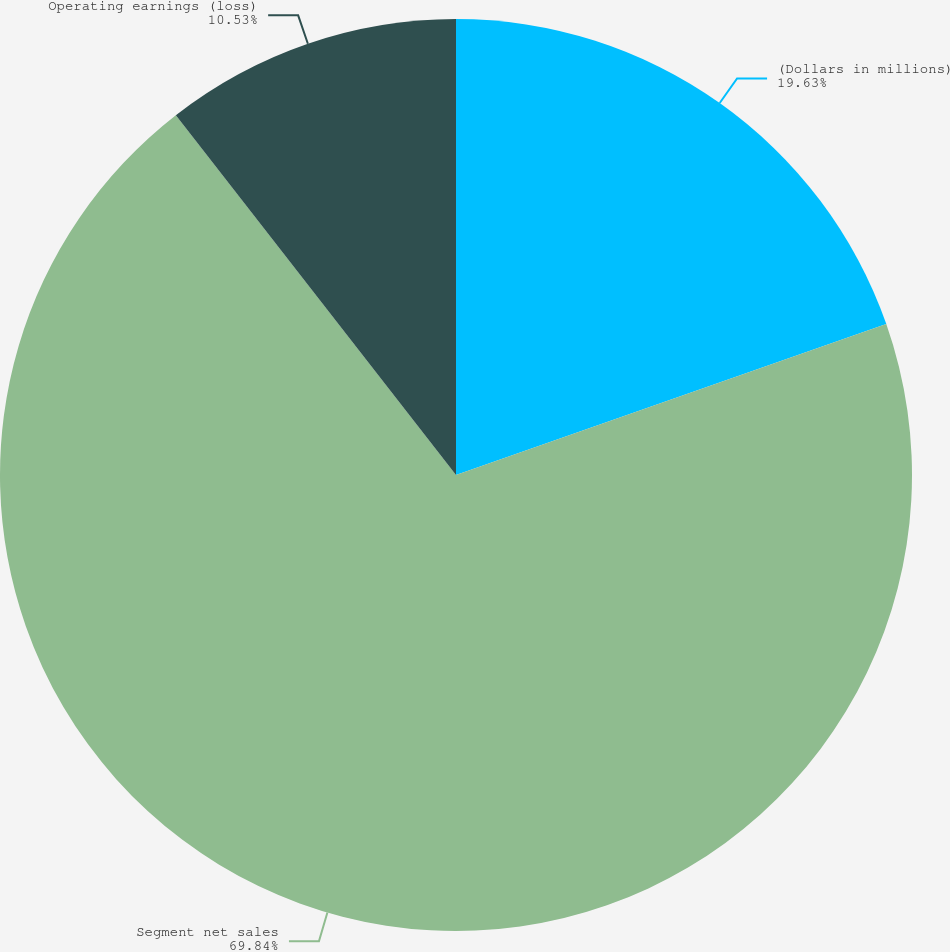Convert chart to OTSL. <chart><loc_0><loc_0><loc_500><loc_500><pie_chart><fcel>(Dollars in millions)<fcel>Segment net sales<fcel>Operating earnings (loss)<nl><fcel>19.63%<fcel>69.84%<fcel>10.53%<nl></chart> 